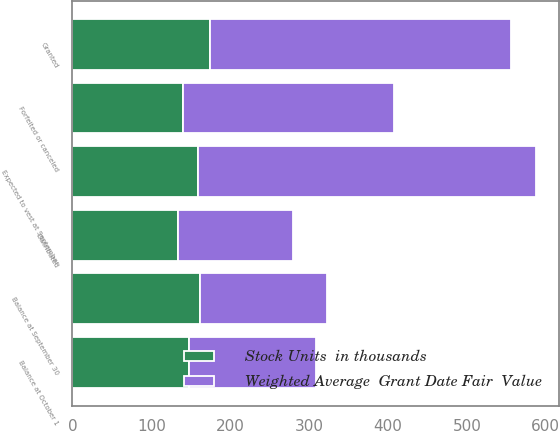<chart> <loc_0><loc_0><loc_500><loc_500><stacked_bar_chart><ecel><fcel>Balance at October 1<fcel>Granted<fcel>Distributed<fcel>Forfeited or canceled<fcel>Balance at September 30<fcel>Expected to vest at September<nl><fcel>Weighted Average  Grant Date Fair  Value<fcel>160.43<fcel>381<fcel>145<fcel>268<fcel>160.43<fcel>428<nl><fcel>Stock Units  in thousands<fcel>148.27<fcel>174.92<fcel>134.19<fcel>139.93<fcel>161.64<fcel>159.22<nl></chart> 